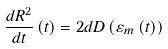<formula> <loc_0><loc_0><loc_500><loc_500>\frac { d R ^ { 2 } } { d t } \left ( t \right ) = 2 d D \left ( \varepsilon _ { m } \left ( t \right ) \right )</formula> 